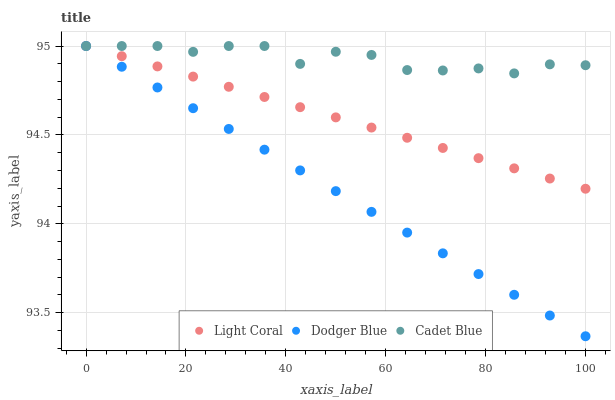Does Dodger Blue have the minimum area under the curve?
Answer yes or no. Yes. Does Cadet Blue have the maximum area under the curve?
Answer yes or no. Yes. Does Cadet Blue have the minimum area under the curve?
Answer yes or no. No. Does Dodger Blue have the maximum area under the curve?
Answer yes or no. No. Is Light Coral the smoothest?
Answer yes or no. Yes. Is Cadet Blue the roughest?
Answer yes or no. Yes. Is Dodger Blue the smoothest?
Answer yes or no. No. Is Dodger Blue the roughest?
Answer yes or no. No. Does Dodger Blue have the lowest value?
Answer yes or no. Yes. Does Cadet Blue have the lowest value?
Answer yes or no. No. Does Dodger Blue have the highest value?
Answer yes or no. Yes. Does Dodger Blue intersect Cadet Blue?
Answer yes or no. Yes. Is Dodger Blue less than Cadet Blue?
Answer yes or no. No. Is Dodger Blue greater than Cadet Blue?
Answer yes or no. No. 